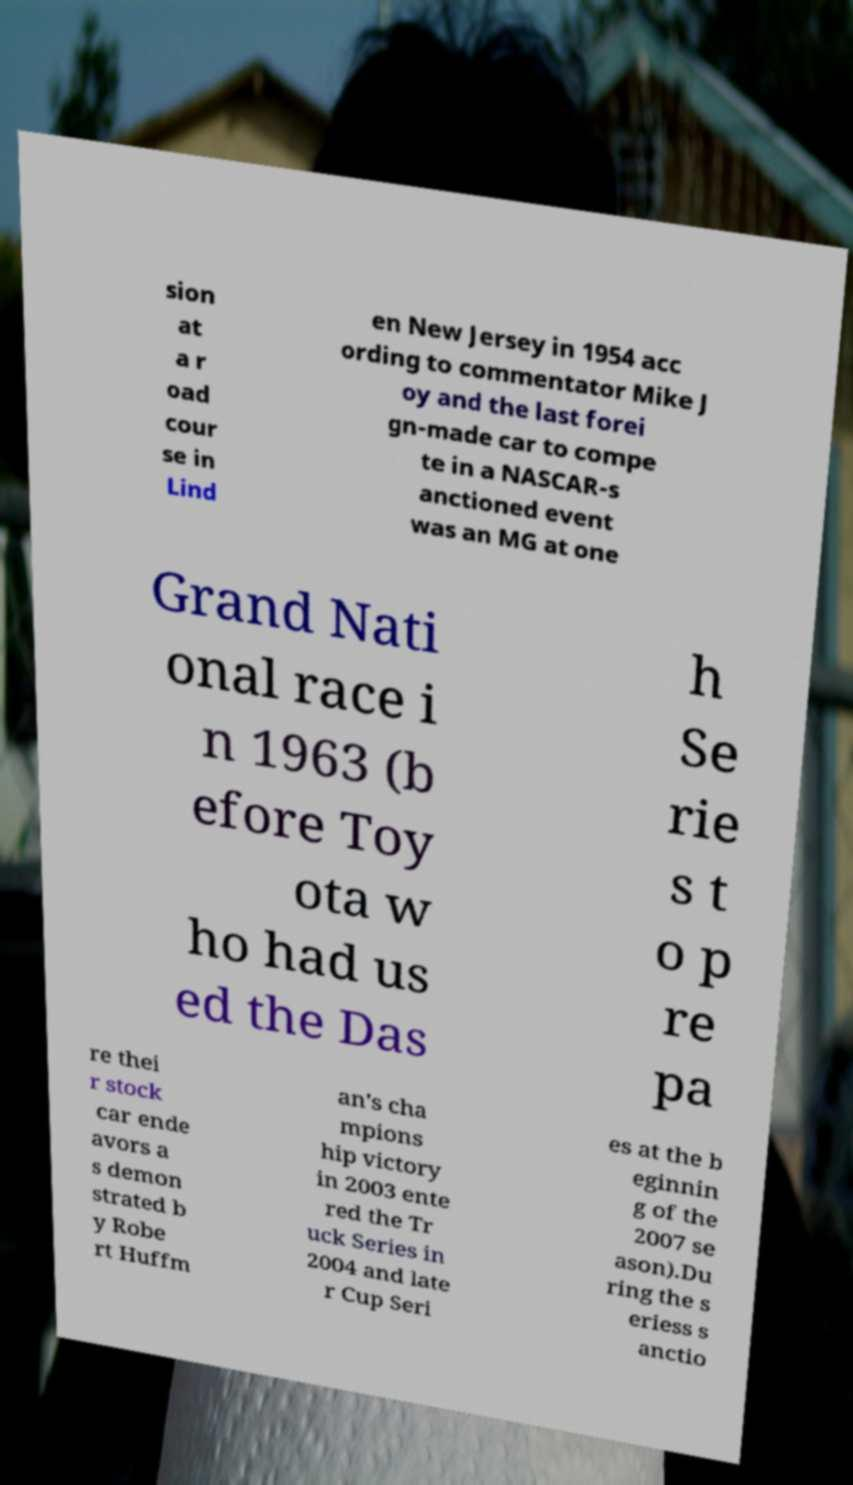Can you accurately transcribe the text from the provided image for me? sion at a r oad cour se in Lind en New Jersey in 1954 acc ording to commentator Mike J oy and the last forei gn-made car to compe te in a NASCAR-s anctioned event was an MG at one Grand Nati onal race i n 1963 (b efore Toy ota w ho had us ed the Das h Se rie s t o p re pa re thei r stock car ende avors a s demon strated b y Robe rt Huffm an's cha mpions hip victory in 2003 ente red the Tr uck Series in 2004 and late r Cup Seri es at the b eginnin g of the 2007 se ason).Du ring the s eriess s anctio 